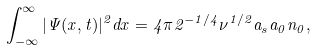<formula> <loc_0><loc_0><loc_500><loc_500>\int _ { - \infty } ^ { \infty } | \Psi ( x , t ) | ^ { 2 } d x = 4 \pi 2 ^ { - 1 / 4 } \nu ^ { 1 / 2 } a _ { s } a _ { 0 } n _ { 0 } ,</formula> 